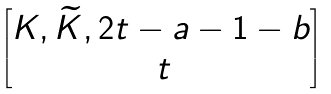Convert formula to latex. <formula><loc_0><loc_0><loc_500><loc_500>\begin{bmatrix} K , \widetilde { K } , 2 t - a - 1 - b \\ \, t \end{bmatrix}</formula> 